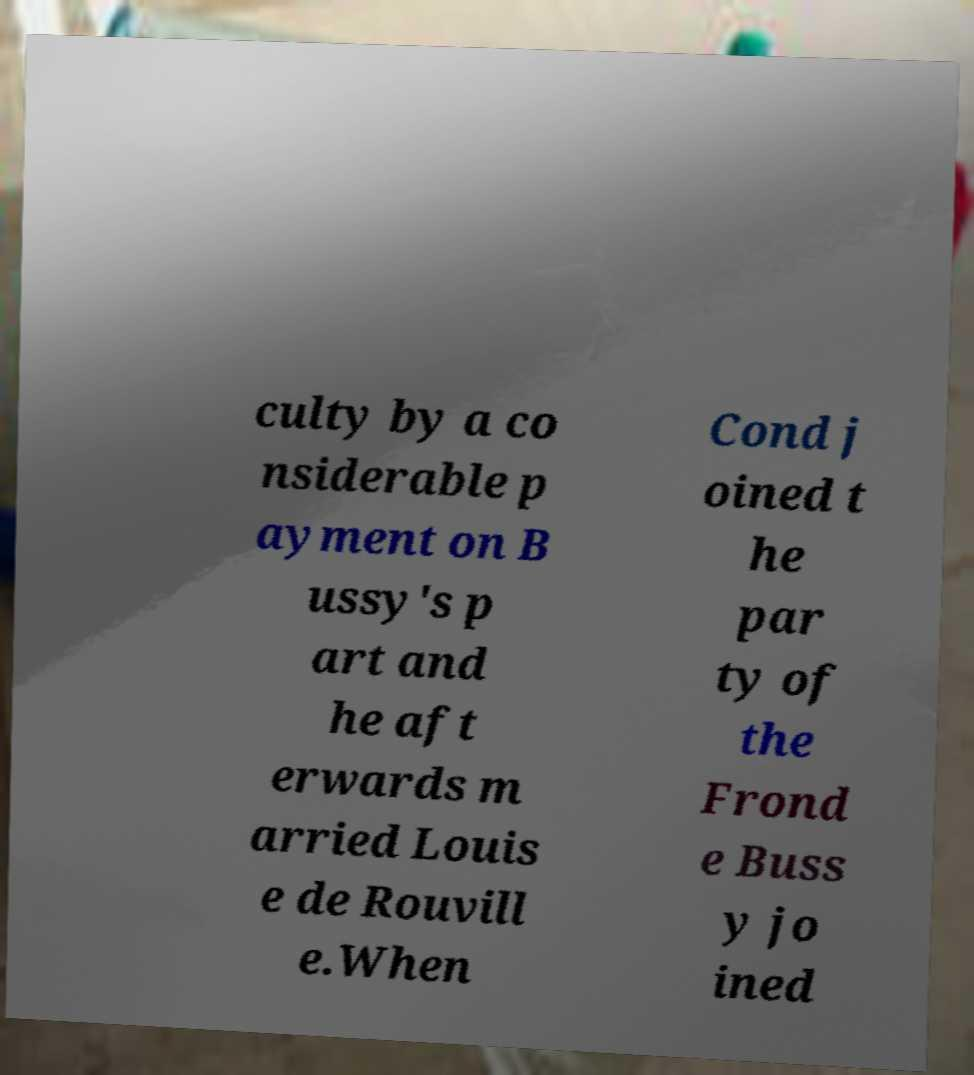Could you extract and type out the text from this image? culty by a co nsiderable p ayment on B ussy's p art and he aft erwards m arried Louis e de Rouvill e.When Cond j oined t he par ty of the Frond e Buss y jo ined 